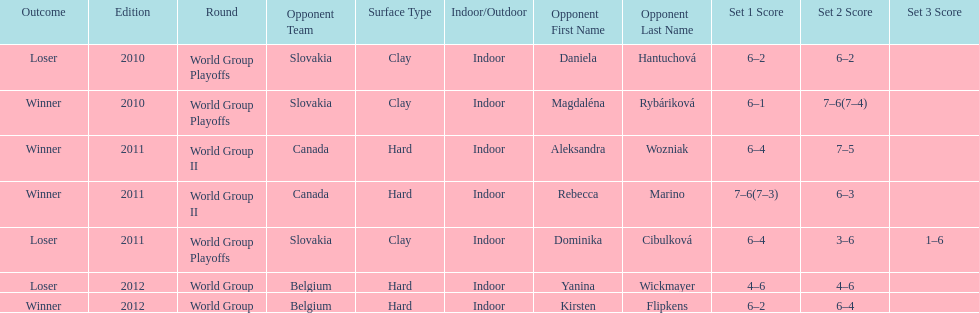Was the game versus canada later than the game versus belgium? No. 